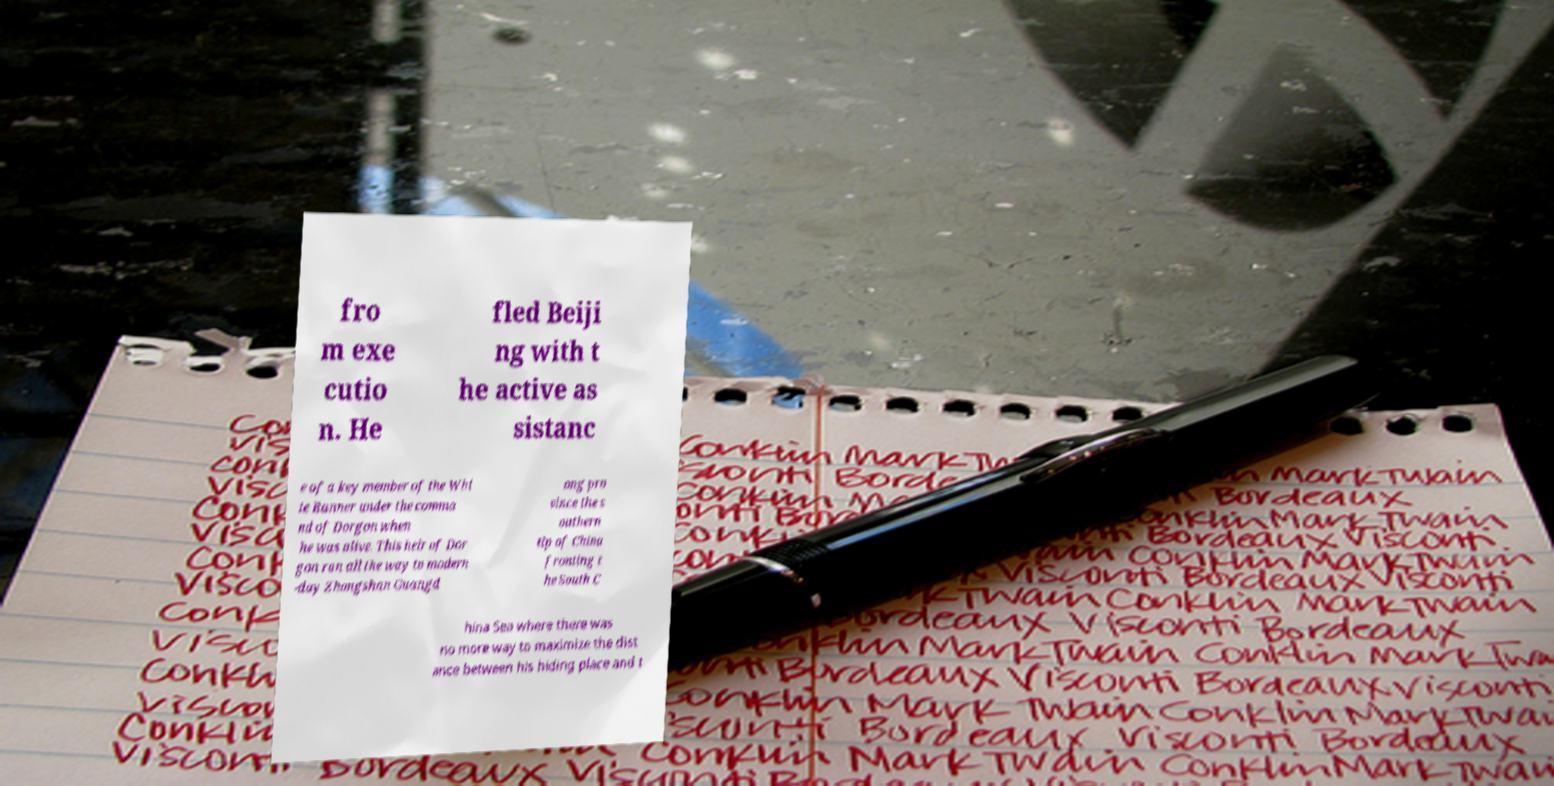Could you extract and type out the text from this image? fro m exe cutio n. He fled Beiji ng with t he active as sistanc e of a key member of the Whi te Banner under the comma nd of Dorgon when he was alive. This heir of Dor gon ran all the way to modern -day Zhongshan Guangd ong pro vince the s outhern tip of China fronting t he South C hina Sea where there was no more way to maximize the dist ance between his hiding place and t 